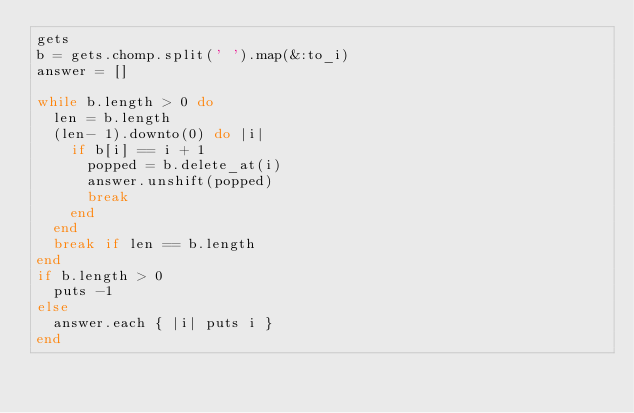Convert code to text. <code><loc_0><loc_0><loc_500><loc_500><_Ruby_>gets
b = gets.chomp.split(' ').map(&:to_i)
answer = []

while b.length > 0 do
  len = b.length
  (len- 1).downto(0) do |i|
    if b[i] == i + 1
      popped = b.delete_at(i)
      answer.unshift(popped)
      break
    end
  end
  break if len == b.length
end
if b.length > 0
  puts -1
else
  answer.each { |i| puts i }
end</code> 